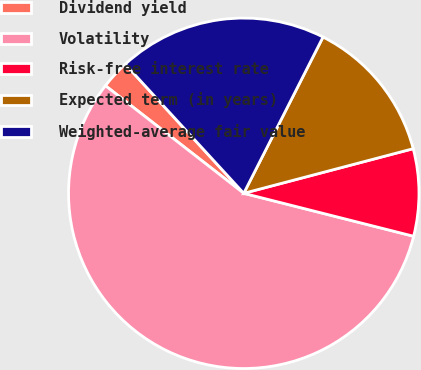Convert chart. <chart><loc_0><loc_0><loc_500><loc_500><pie_chart><fcel>Dividend yield<fcel>Volatility<fcel>Risk-free interest rate<fcel>Expected term (in years)<fcel>Weighted-average fair value<nl><fcel>2.66%<fcel>56.58%<fcel>8.04%<fcel>13.43%<fcel>19.29%<nl></chart> 